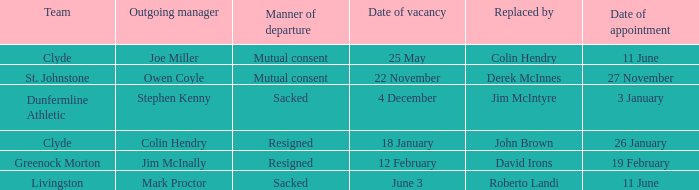I want to know the team that was terminated and date of vacancy was 4 december. Dunfermline Athletic. 